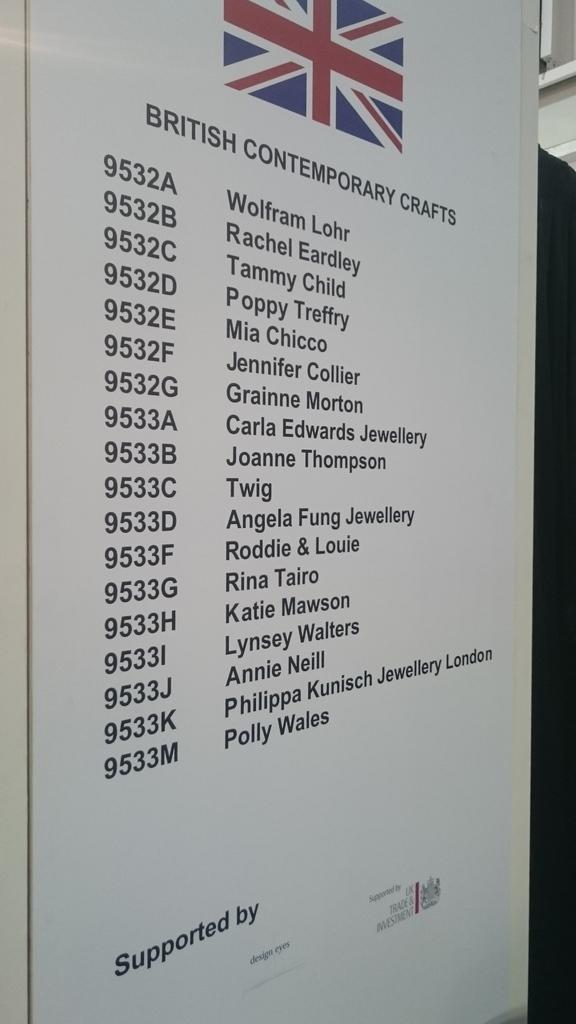<image>
Render a clear and concise summary of the photo. A list that shows all the british contemporary crafts for an event. 